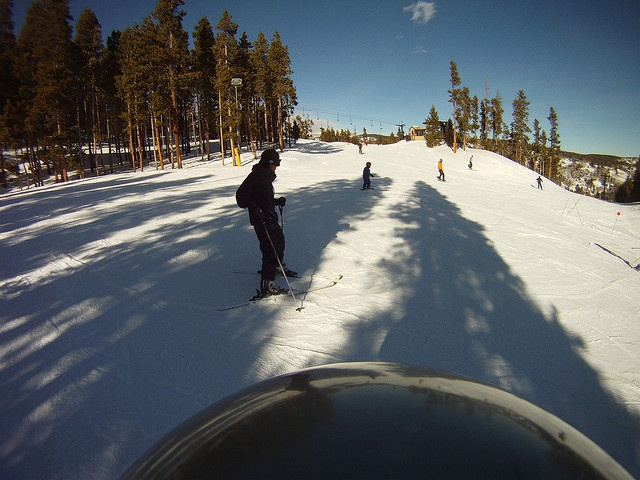Describe the objects in this image and their specific colors. I can see people in black, gray, blue, and ivory tones, skis in black, gray, darkblue, and beige tones, backpack in black and gray tones, people in black, gray, and beige tones, and people in black, orange, and gray tones in this image. 